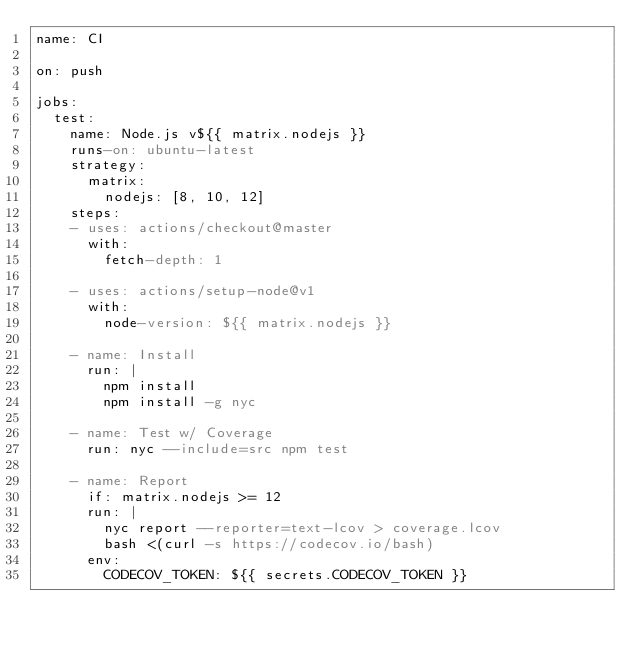Convert code to text. <code><loc_0><loc_0><loc_500><loc_500><_YAML_>name: CI

on: push

jobs:
  test:
    name: Node.js v${{ matrix.nodejs }}
    runs-on: ubuntu-latest
    strategy:
      matrix:
        nodejs: [8, 10, 12]
    steps:
    - uses: actions/checkout@master
      with:
        fetch-depth: 1

    - uses: actions/setup-node@v1
      with:
        node-version: ${{ matrix.nodejs }}

    - name: Install
      run: |
        npm install
        npm install -g nyc

    - name: Test w/ Coverage
      run: nyc --include=src npm test

    - name: Report
      if: matrix.nodejs >= 12
      run: |
        nyc report --reporter=text-lcov > coverage.lcov
        bash <(curl -s https://codecov.io/bash)
      env:
        CODECOV_TOKEN: ${{ secrets.CODECOV_TOKEN }}
</code> 